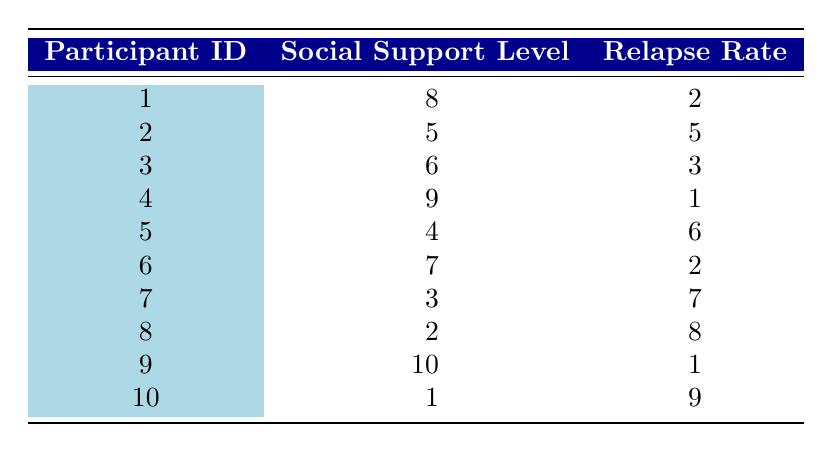What is the social support level of Participant ID 7? According to the table, under the column labeled "Social Support Level," the value for Participant ID 7 is clearly listed as 3.
Answer: 3 What is the relapse rate for the participant with the highest social support level? Among all participants, Participant ID 9 has the highest social support level at 10, and the corresponding relapse rate for this participant is listed as 1 in the table.
Answer: 1 Is there a participant with a social support level of 1? By examining the table, we can see that Participant ID 10 has a social support level of 1; thus, the statement is true.
Answer: Yes What is the average relapse rate of participants with a social support level greater than 5? The participants with social support levels greater than 5 are IDs 1 (2), 4 (1), 6 (2), and 9 (1), whose relapse rates are 2, 1, 2, and 1 respectively. Summing these gives 2 + 1 + 2 + 1 = 6. There are 4 such participants, so the average is 6 / 4 = 1.5.
Answer: 1.5 Which participant has the highest relapse rate and what is that rate? By scanning the "Relapse Rate" column in the table, the highest value is 9, which belongs to Participant ID 10.
Answer: 9 How many participants have a social support level of 5 or lower? Looking through the table, Participants ID 2 (5), 5 (4), 7 (3), 8 (2), and 10 (1) all have social support levels of 5 or lower. Counting these participants, there are a total of 5.
Answer: 5 What is the difference in social support levels between the participants with the highest and lowest relapse rates? From the table, Participant ID 4 has the lowest relapse rate of 1 and a social support level of 9, while Participant ID 10 has the highest relapse rate of 9 and a social support level of 1. The difference in social support levels is 9 (Participant 4) - 1 (Participant 10) = 8.
Answer: 8 Do participants with higher social support levels generally have lower relapse rates based on this table? A review of the "Social Support Level" and "Relapse Rate" columns suggests that as social support levels increase, relapse rates tend to decrease. For example, Participant ID 9 has the highest social support level (10) and the lowest relapse rate (1), suggesting a negative correlation. Thus, the statement appears to be true.
Answer: Yes 